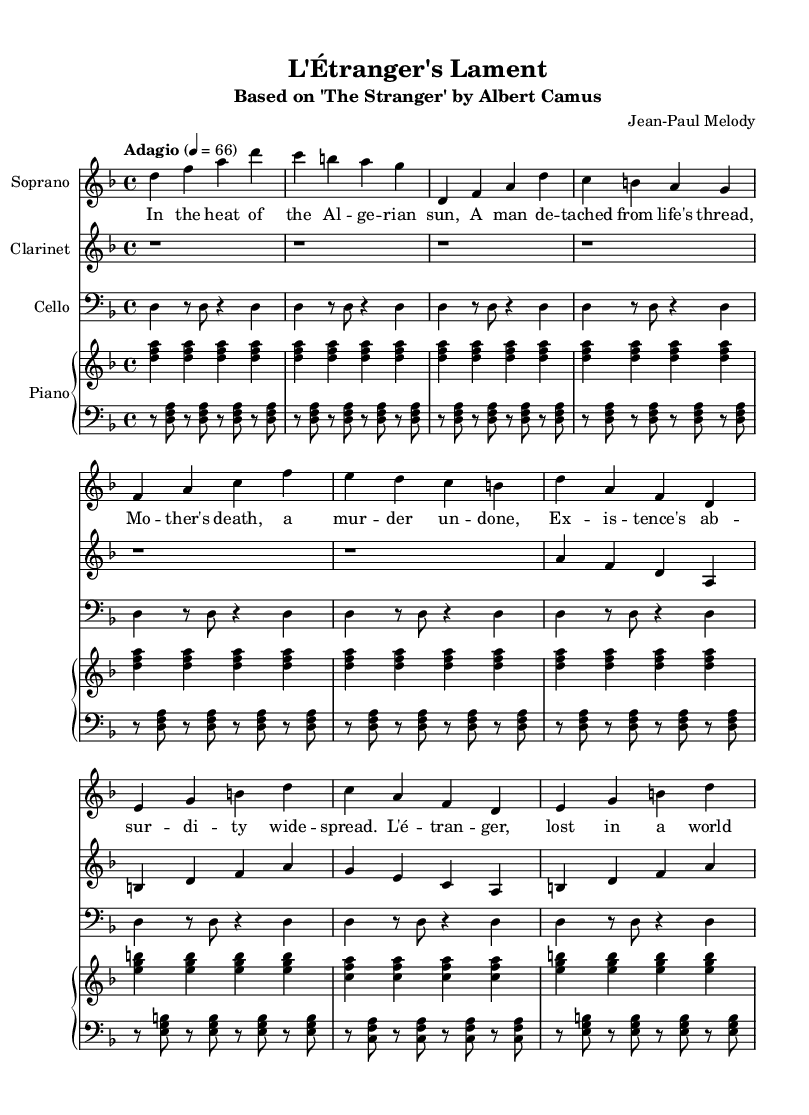What is the key signature of this music? The key signature is indicated at the beginning of the staff and shows one flat, which defines it as D minor.
Answer: D minor What is the time signature of this music? The time signature is located at the beginning of the score, showing "4/4" which indicates four beats per measure.
Answer: 4/4 What is the tempo marking of this music? The tempo marking is found near the beginning of the score, indicating "Adagio" and a tempo of 66 beats per minute.
Answer: Adagio How many instruments are featured in this score? By counting the unique instrumental staves presented, there are four: soprano, clarinet, cello, and piano (with two staves for the piano).
Answer: Four What is the title of this opera? The title is found at the top of the score, announcing it as "L'Étranger's Lament."
Answer: L'Étranger's Lament What is the main theme of the lyrics in this opera? The lyrics reflect on themes of existentialism and detachment, as suggested by the phrases about indifference and facing the void.
Answer: Existentialism What character from a novel is this opera based on? The opera is based on "The Stranger," a novel by Albert Camus, which is indicated in the subtitle of the score.
Answer: The Stranger 